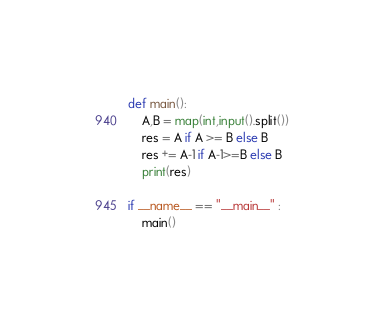<code> <loc_0><loc_0><loc_500><loc_500><_Python_>
def main():
	A,B = map(int,input().split())
	res = A if A >= B else B
	res += A-1 if A-1>=B else B
	print(res)

if __name__ == "__main__" :
	main()</code> 